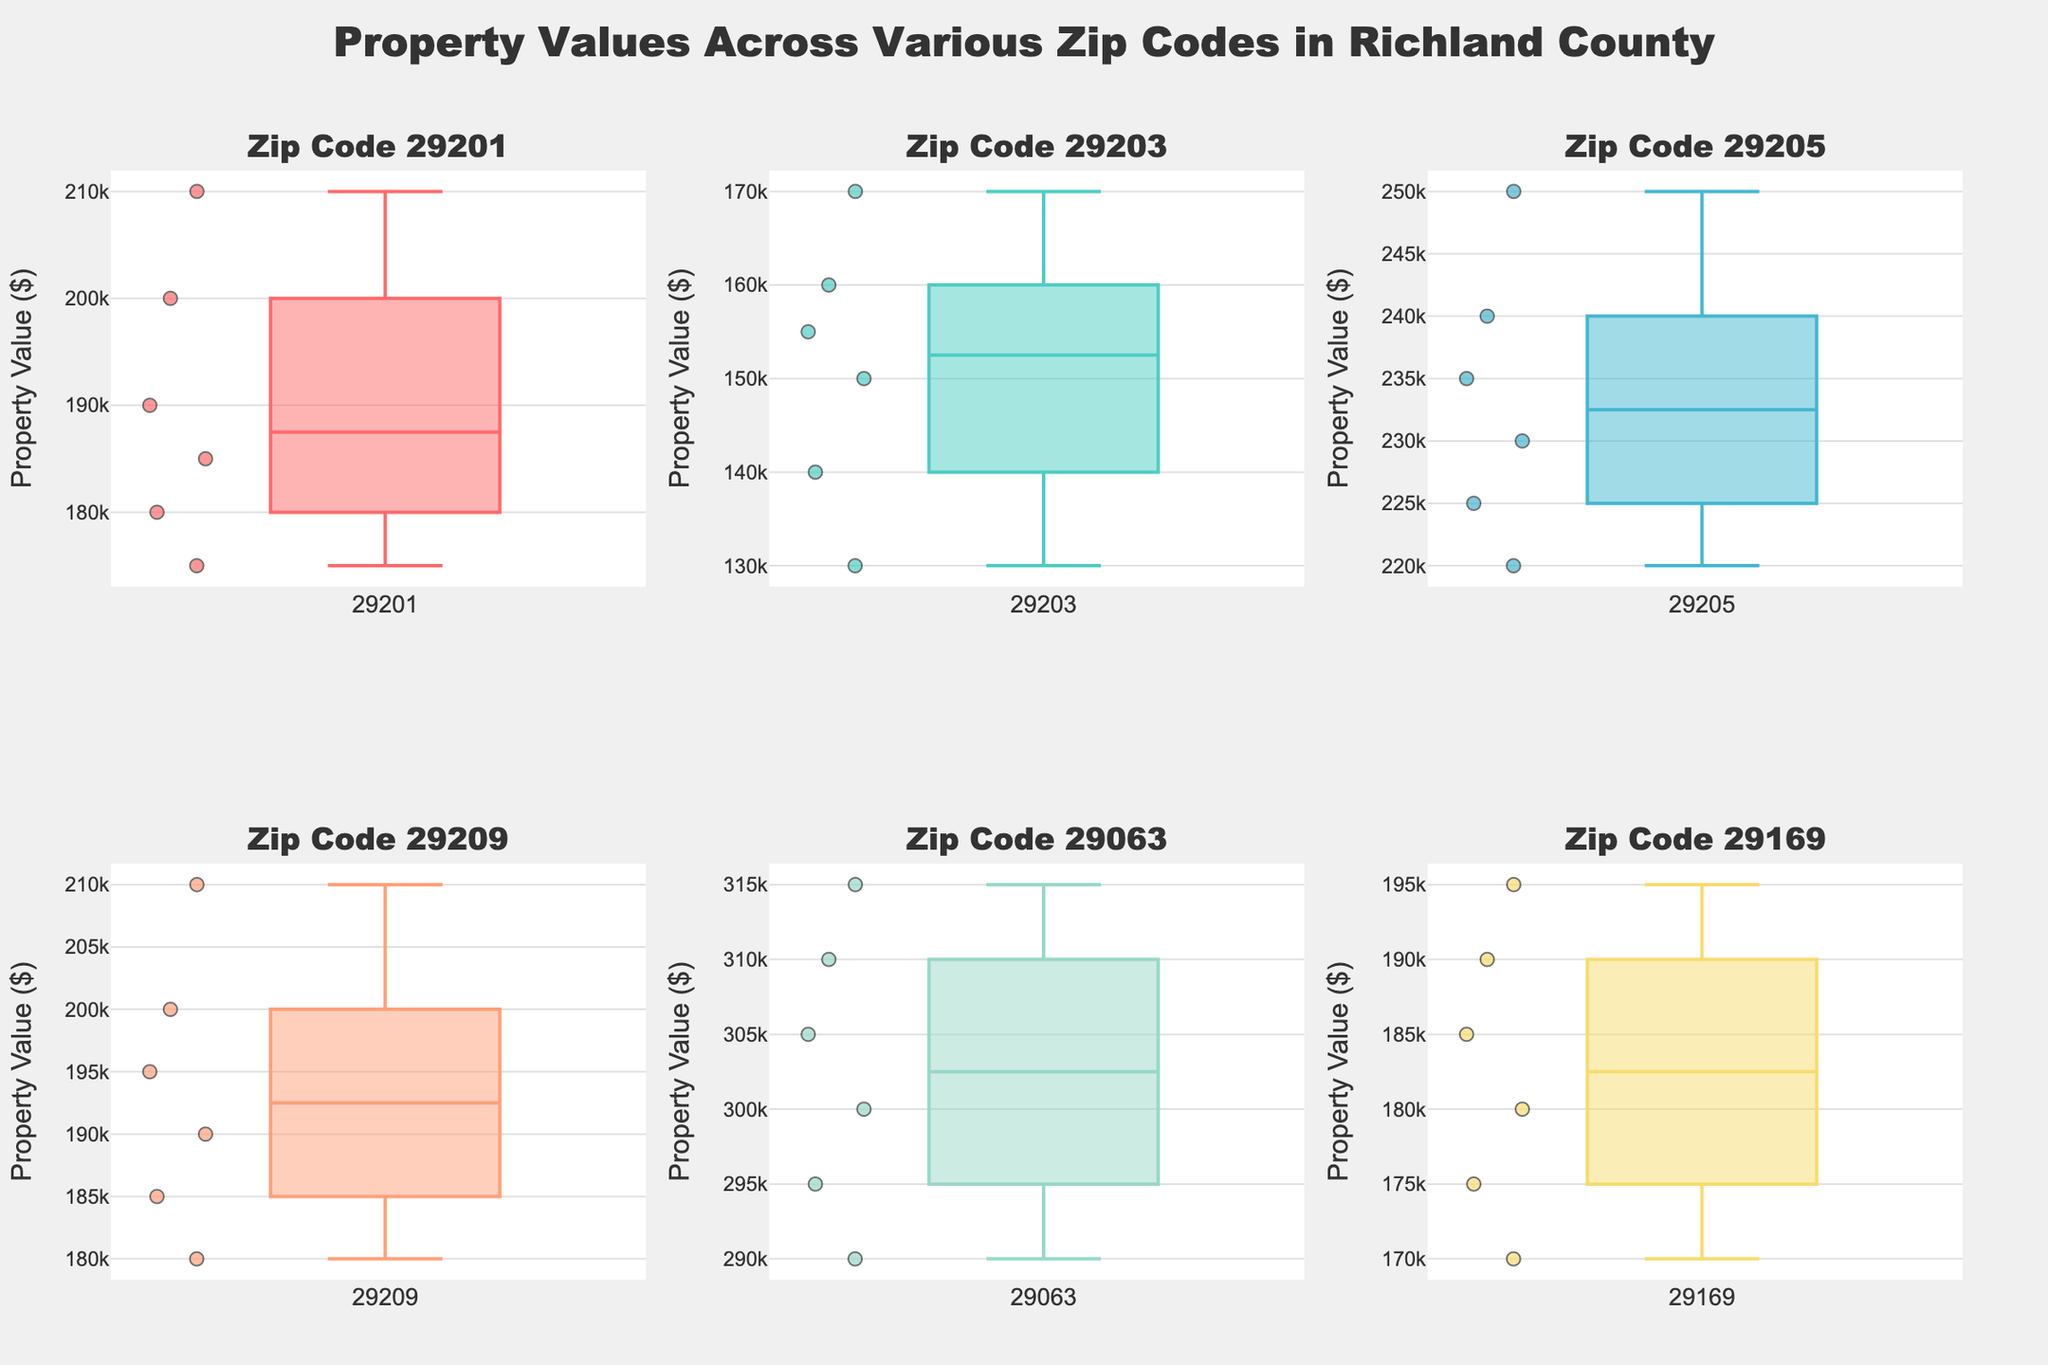What is the title of the figure? The title is located at the top center of the figure and it succinctly describes the subject of the plot. In this case, the title reads "Property Values Across Various Zip Codes in Richland County".
Answer: Property Values Across Various Zip Codes in Richland County How many zip codes are displayed in the box plots? The subplot titles, which are shown above each box plot, correspond to each unique zip code. By counting these subtitles, we can determine the number of zip codes. There are six unique zip codes displayed in the figure: 29201, 29203, 29205, 29209, 29063, and 29169.
Answer: Six Which zip code has the highest median property value? The median value in a box plot is indicated by the line within the box. By comparing across the subplots, we can identify the zip code with the highest median. For the zip code 29063, the median value is clearly higher than the others.
Answer: 29063 What is the approximate range of property values for the zip code 29205? In a box plot, the range is the difference between the maximum and minimum values, represented by the top and bottom whiskers. For the zip code 29205, the property values range approximately from 220,000 to 250,000.
Answer: 220,000 to 250,000 Which zip code shows the greatest variability in property values? Variability can be gauged by the spread of the box and whiskers. Larger distances between these elements indicate higher variability. The zip code 29063 shows the greatest variability, as the spread is the widest among the displayed box plots.
Answer: 29063 Between zip codes 29201 and 29209, which one has a higher median property value? The median is indicated by the line inside the box. By comparing the median lines in the box plots for 29201 and 29209, it is evident that zip code 29209 has a higher median property value.
Answer: 29209 What is the shortest range of property values among the zip codes, and which zip code does it correspond to? The shortest range can be identified by finding the plot with the smallest difference between its maximum and minimum values (whiskers). The range for zip code 29201 is the shortest, with values approximately between 175,000 and 210,000.
Answer: 29201 Comparing zip codes 29169 and 29203, which one has the lower median property value? By examining the median lines in the respective box plots, it is clear that the median property value for zip code 29203 is lower than that for zip code 29169.
Answer: 29203 Are there any outliers in the property values for the zip code 29203? Outliers in a box plot are usually shown as individual points beyond the whiskers. For the zip code 29203, there are no individual points that lie noticeably beyond the range of the whiskers, indicating no outliers.
Answer: No What is the interquartile range (IQR) for zip code 29209? The IQR is the range of the middle 50% of values, represented by the box in a box plot. For zip code 29209, the IQR is from approximately 185,000 to 200,000. Subtracting these values gives an IQR of 15,000.
Answer: 15,000 